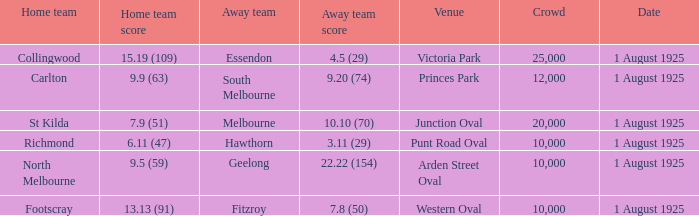Which match where Hawthorn was the away team had the largest crowd? 10000.0. 